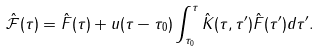<formula> <loc_0><loc_0><loc_500><loc_500>\hat { \mathcal { F } } ( \tau ) = \hat { F } ( \tau ) + u ( \tau - \tau _ { 0 } ) \int ^ { \tau } _ { \tau _ { 0 } } \hat { K } ( \tau , \tau ^ { \prime } ) \hat { F } ( \tau ^ { \prime } ) d \tau ^ { \prime } .</formula> 